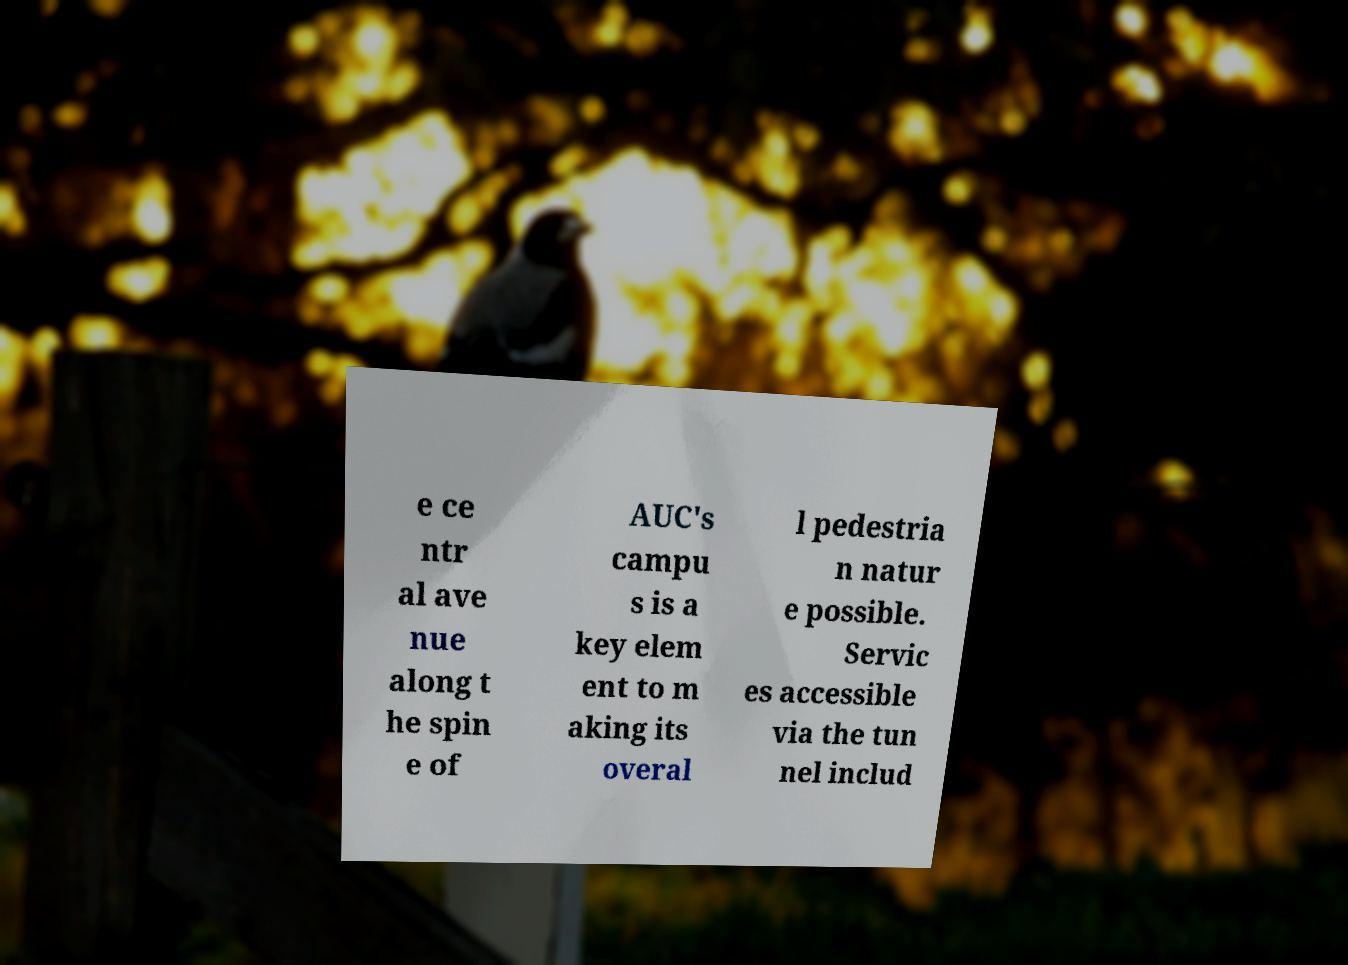Could you extract and type out the text from this image? e ce ntr al ave nue along t he spin e of AUC's campu s is a key elem ent to m aking its overal l pedestria n natur e possible. Servic es accessible via the tun nel includ 